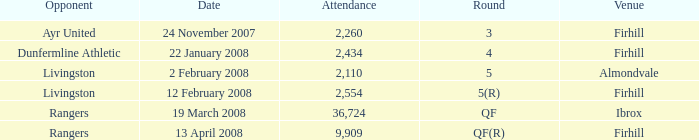What is the average attendance at a game held at Firhill for the 5(r) round? 2554.0. 